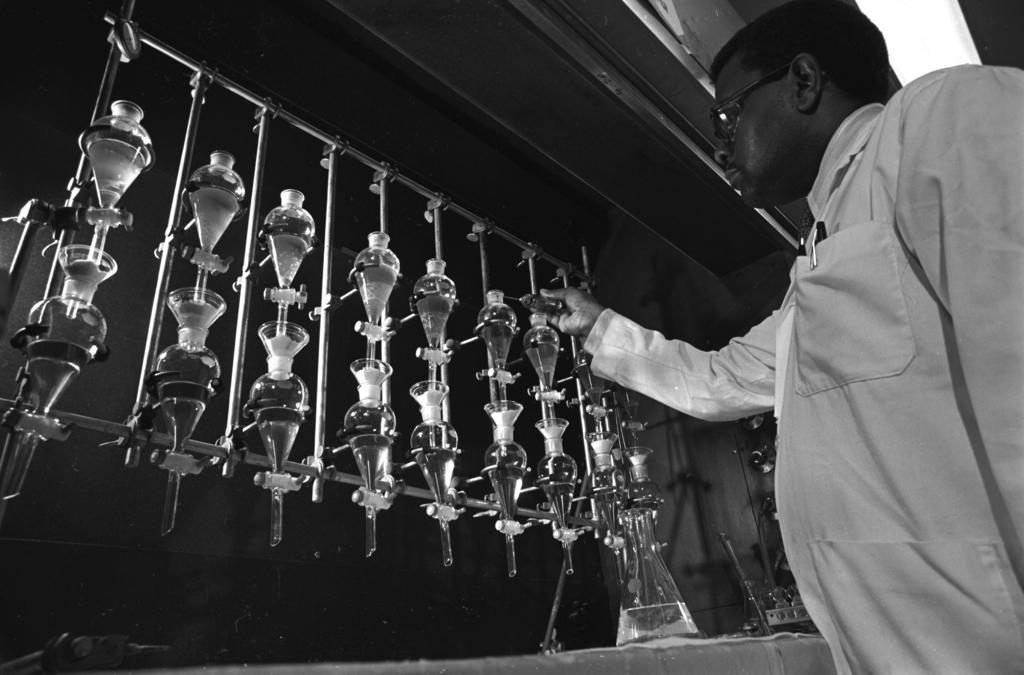Please provide a concise description of this image. In the foreground of this black and white image, On the right, there is a man standing and on the left, there are laboratory utensils and the wall. 